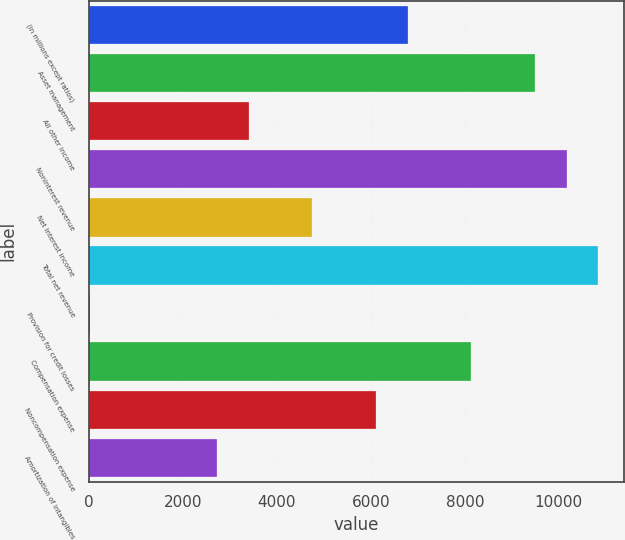Convert chart to OTSL. <chart><loc_0><loc_0><loc_500><loc_500><bar_chart><fcel>(in millions except ratios)<fcel>Asset management<fcel>All other income<fcel>Noninterest revenue<fcel>Net interest income<fcel>Total net revenue<fcel>Provision for credit losses<fcel>Compensation expense<fcel>Noncompensation expense<fcel>Amortization of intangibles<nl><fcel>6787<fcel>9490.6<fcel>3407.5<fcel>10166.5<fcel>4759.3<fcel>10842.4<fcel>28<fcel>8138.8<fcel>6111.1<fcel>2731.6<nl></chart> 